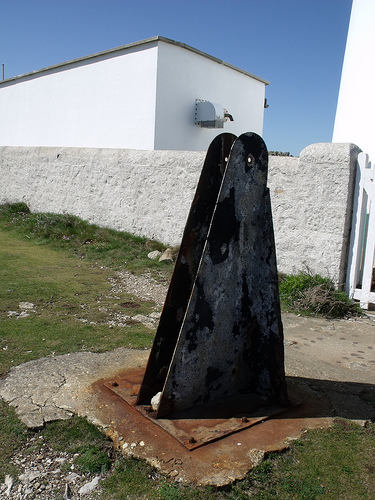<image>
Can you confirm if the house is behind the wall? Yes. From this viewpoint, the house is positioned behind the wall, with the wall partially or fully occluding the house. 